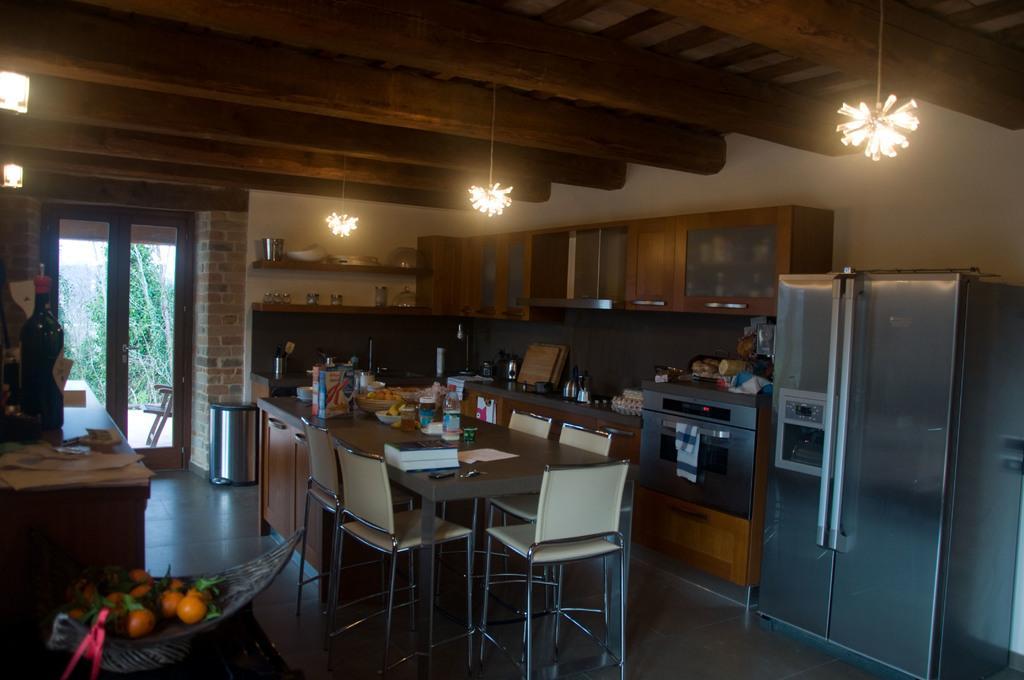Please provide a concise description of this image. In this image we can see table with chairs. On the table there is a basket, packets and many other items. On the left side there is a tray with fruits. Also there is a table with bottle and some other items. On the right side there is a fridge. And there is a platform. On that there are many items. And there is a cupboard on the wall. On the cupboard there are bowls and some other items. On the ceiling there are lights. In the back there are doors and there is a brick wall. Near to that there is a dustbin. Through the doors we can see trees. 